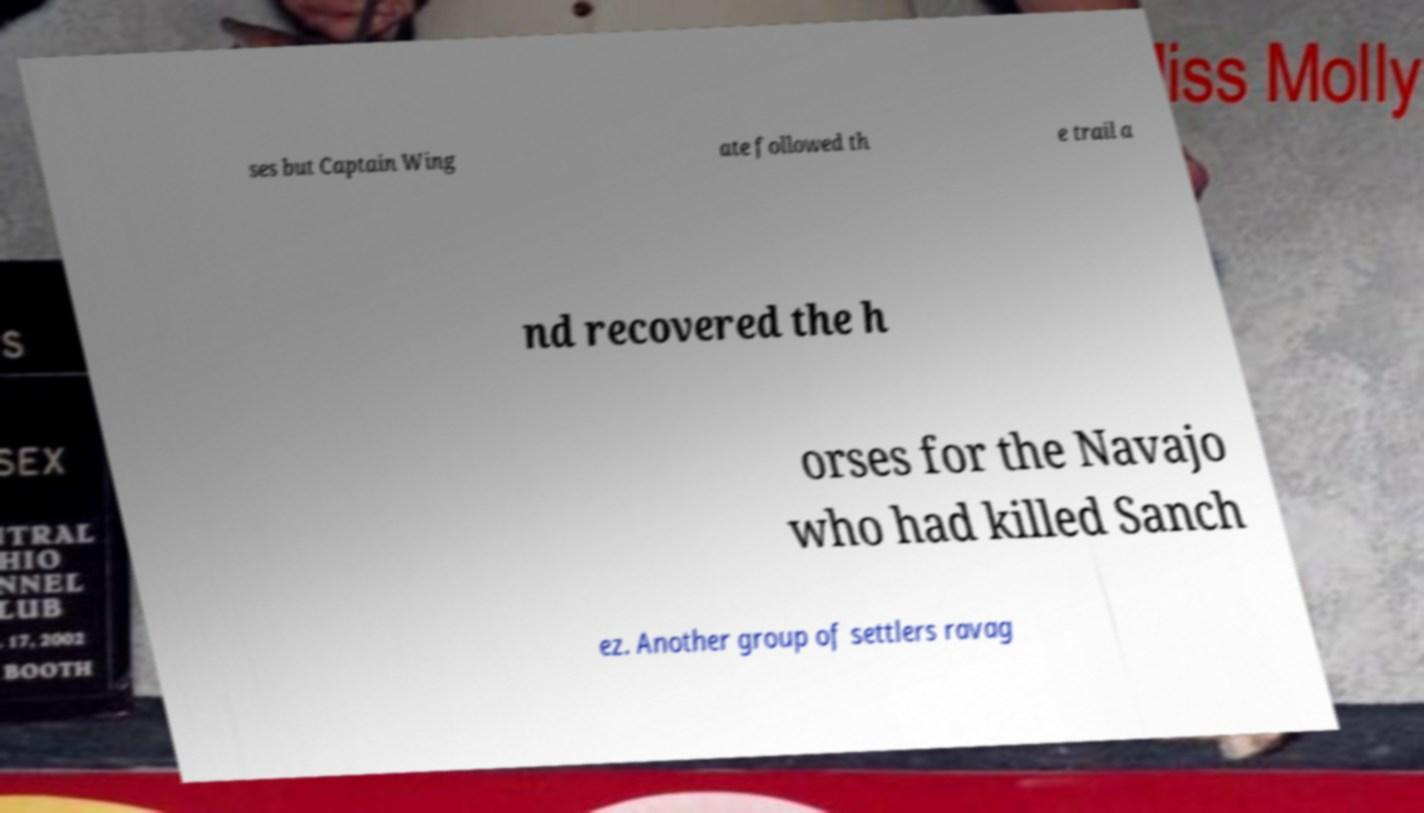For documentation purposes, I need the text within this image transcribed. Could you provide that? ses but Captain Wing ate followed th e trail a nd recovered the h orses for the Navajo who had killed Sanch ez. Another group of settlers ravag 